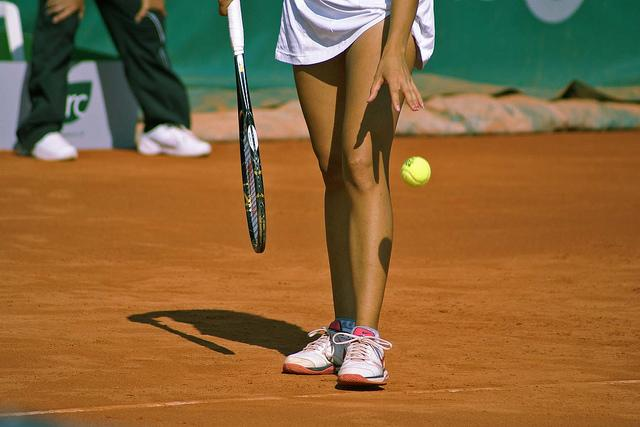What will the person here do next in the game? serve 